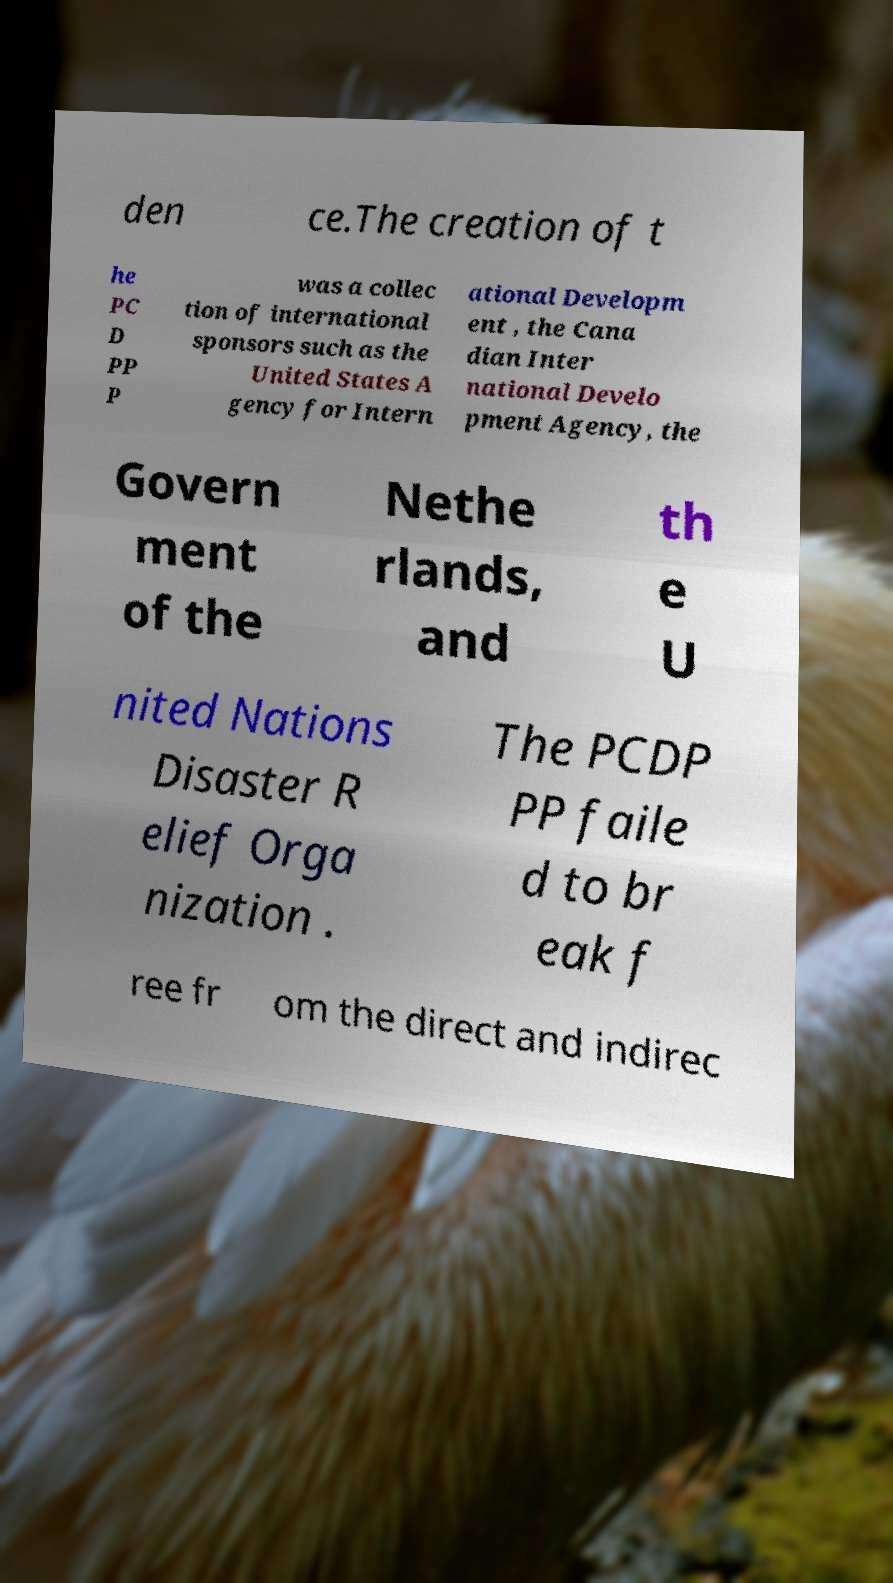Please identify and transcribe the text found in this image. den ce.The creation of t he PC D PP P was a collec tion of international sponsors such as the United States A gency for Intern ational Developm ent , the Cana dian Inter national Develo pment Agency, the Govern ment of the Nethe rlands, and th e U nited Nations Disaster R elief Orga nization . The PCDP PP faile d to br eak f ree fr om the direct and indirec 